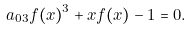<formula> <loc_0><loc_0><loc_500><loc_500>a _ { 0 3 } f ( x ) ^ { 3 } + x f ( x ) - 1 = 0 .</formula> 